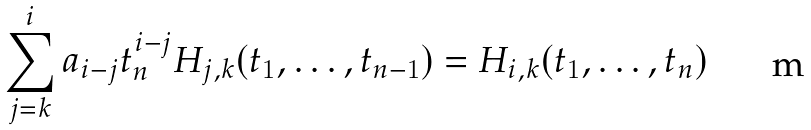<formula> <loc_0><loc_0><loc_500><loc_500>\sum _ { j = k } ^ { i } a _ { i - j } t _ { n } ^ { i - j } H _ { j , k } ( t _ { 1 } , \dots , t _ { n - 1 } ) = H _ { i , k } ( t _ { 1 } , \dots , t _ { n } )</formula> 